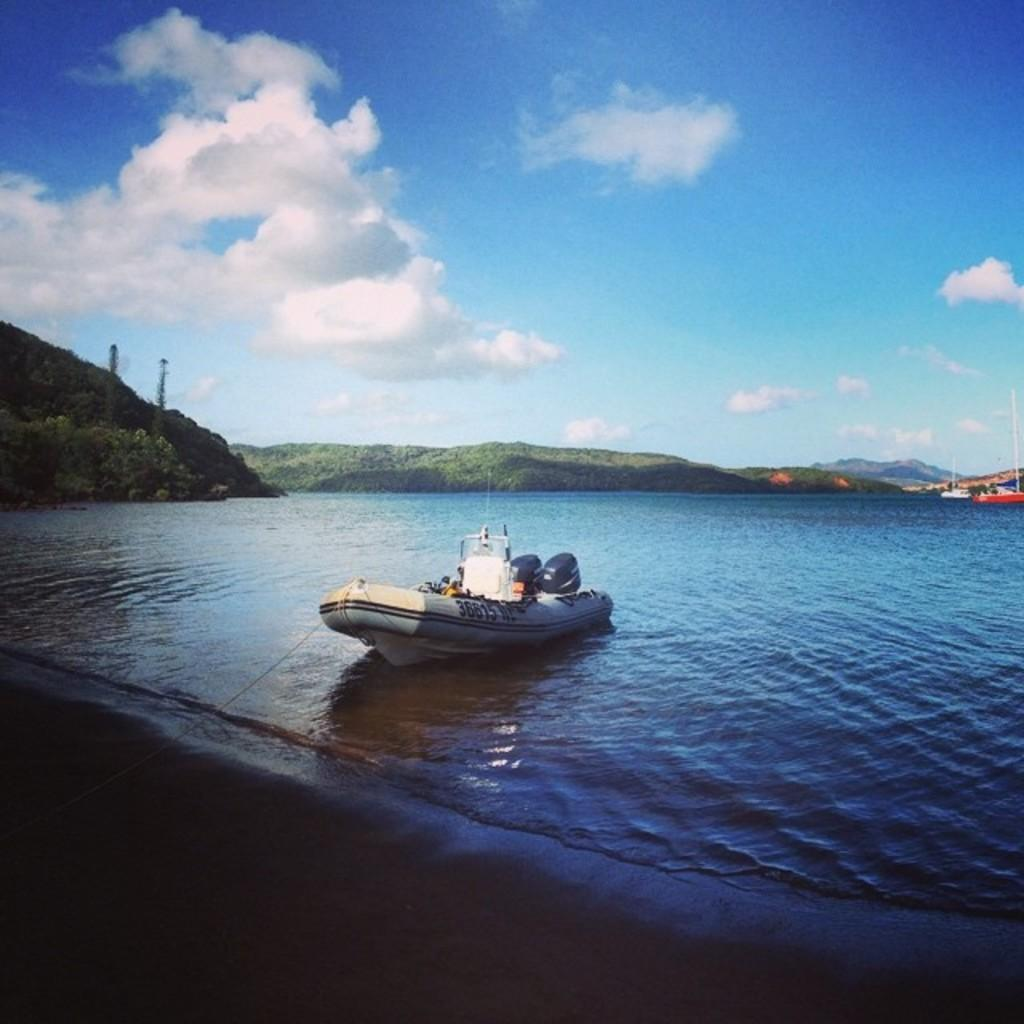What is in the water in the image? There are boats in the water in the image. What can be seen in the background of the image? There are trees, mountains, and the sky visible in the background of the image. What is the condition of the sky in the image? Clouds are present in the sky in the image. What type of paint is being used to decorate the kitten in the image? There is no kitten present in the image, so there is no paint being used to decorate it. Is there a party happening in the image? There is no indication of a party in the image; it features boats in the water with trees, mountains, and clouds in the background. 